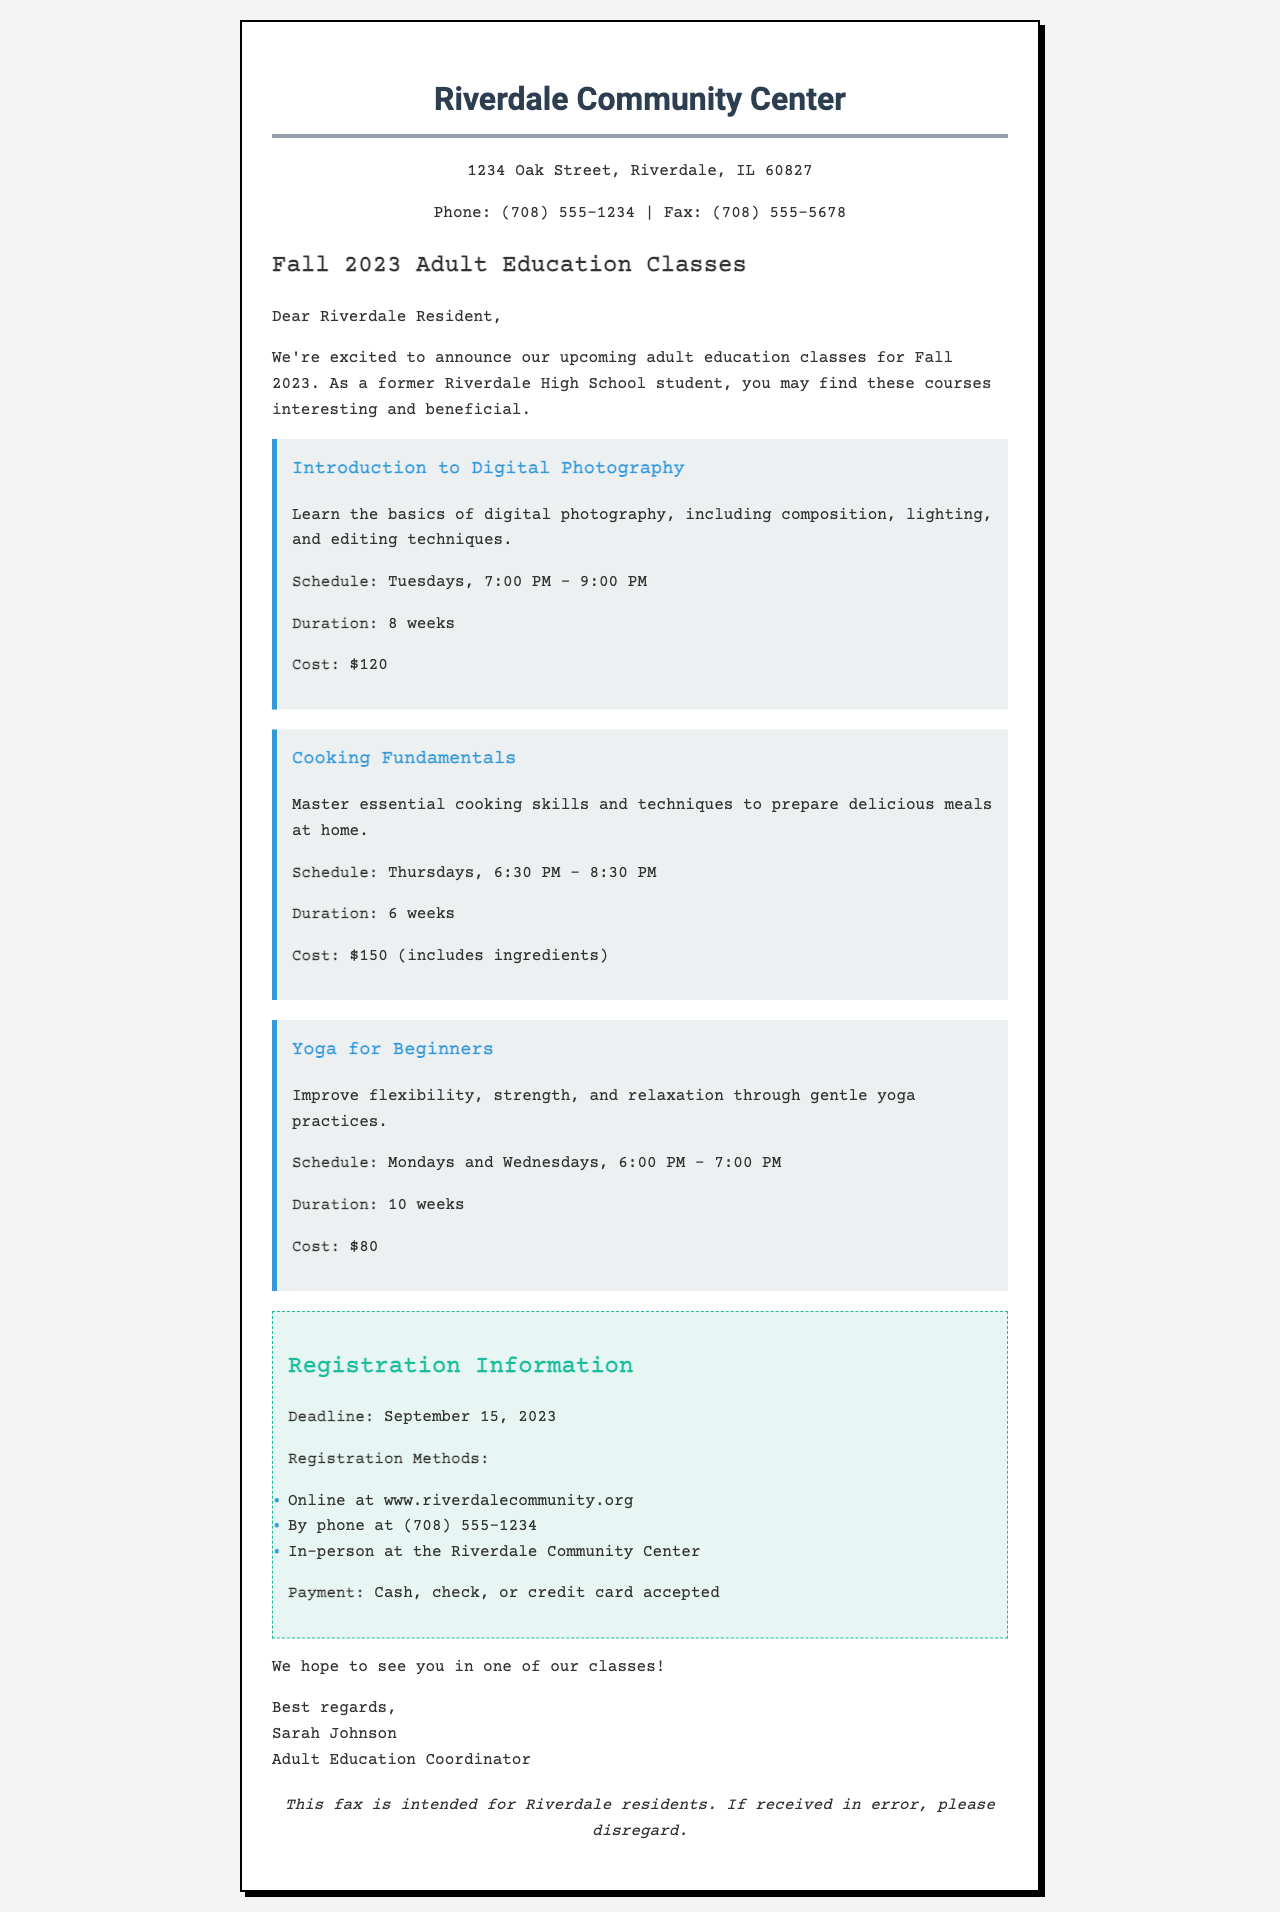what is the location of the Riverdale Community Center? The document states the address at the beginning.
Answer: 1234 Oak Street, Riverdale, IL 60827 who is the Adult Education Coordinator? Sarah Johnson is mentioned at the end of the document.
Answer: Sarah Johnson what is the cost of the Cooking Fundamentals course? The cost is stated in the course description.
Answer: $150 (includes ingredients) how long does the Yoga for Beginners course last? The duration is detailed in the course description.
Answer: 10 weeks what is the registration deadline? The document clearly indicates the deadline.
Answer: September 15, 2023 which method is not listed for registration? The question points to methods given in the registration section; the answer is not part of the document.
Answer: Mail how many weeks is the Introduction to Digital Photography course? The duration is provided in the course details.
Answer: 8 weeks on which days is the Yoga for Beginners course held? The schedule mentioned in the course description specifies the days.
Answer: Mondays and Wednesdays what time does the Cooking Fundamentals class start? The start time is included in the course's schedule.
Answer: 6:30 PM 